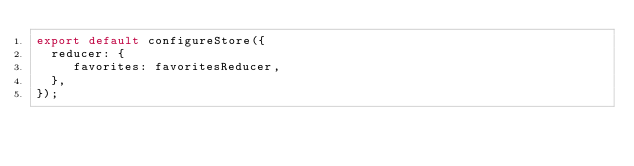<code> <loc_0><loc_0><loc_500><loc_500><_JavaScript_>export default configureStore({
  reducer: {
     favorites: favoritesReducer,
  },
});
</code> 